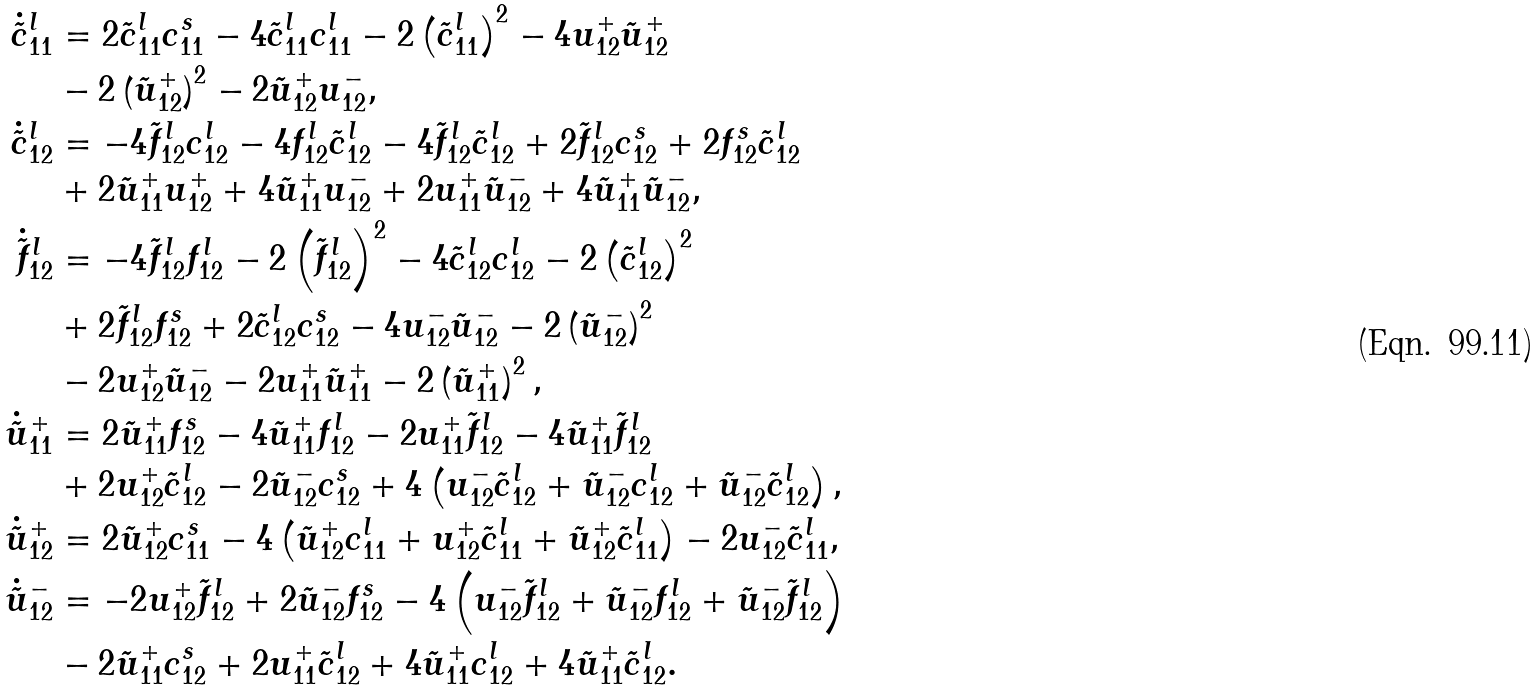Convert formula to latex. <formula><loc_0><loc_0><loc_500><loc_500>\dot { \tilde { c } } ^ { l } _ { 1 1 } & = 2 \tilde { c } ^ { l } _ { 1 1 } c ^ { s } _ { 1 1 } - 4 \tilde { c } ^ { l } _ { 1 1 } c ^ { l } _ { 1 1 } - 2 \left ( \tilde { c } ^ { l } _ { 1 1 } \right ) ^ { 2 } - 4 u _ { 1 2 } ^ { + } \tilde { u } _ { 1 2 } ^ { + } \\ & - 2 \left ( \tilde { u } _ { 1 2 } ^ { + } \right ) ^ { 2 } - 2 \tilde { u } _ { 1 2 } ^ { + } u _ { 1 2 } ^ { - } , \\ \dot { \tilde { c } } ^ { l } _ { 1 2 } & = - 4 \tilde { f } ^ { l } _ { 1 2 } c ^ { l } _ { 1 2 } - 4 f ^ { l } _ { 1 2 } \tilde { c } ^ { l } _ { 1 2 } - 4 \tilde { f } ^ { l } _ { 1 2 } \tilde { c } ^ { l } _ { 1 2 } + 2 \tilde { f } ^ { l } _ { 1 2 } c ^ { s } _ { 1 2 } + 2 f ^ { s } _ { 1 2 } \tilde { c } ^ { l } _ { 1 2 } \\ & + 2 \tilde { u } _ { 1 1 } ^ { + } u _ { 1 2 } ^ { + } + 4 \tilde { u } _ { 1 1 } ^ { + } u _ { 1 2 } ^ { - } + 2 u _ { 1 1 } ^ { + } \tilde { u } _ { 1 2 } ^ { - } + 4 \tilde { u } _ { 1 1 } ^ { + } \tilde { u } _ { 1 2 } ^ { - } , \\ \dot { \tilde { f } } ^ { l } _ { 1 2 } & = - 4 \tilde { f } ^ { l } _ { 1 2 } f ^ { l } _ { 1 2 } - 2 \left ( \tilde { f } ^ { l } _ { 1 2 } \right ) ^ { 2 } - 4 \tilde { c } ^ { l } _ { 1 2 } c ^ { l } _ { 1 2 } - 2 \left ( \tilde { c } ^ { l } _ { 1 2 } \right ) ^ { 2 } \\ & + 2 \tilde { f } ^ { l } _ { 1 2 } f ^ { s } _ { 1 2 } + 2 \tilde { c } ^ { l } _ { 1 2 } c ^ { s } _ { 1 2 } - 4 u _ { 1 2 } ^ { - } \tilde { u } _ { 1 2 } ^ { - } - 2 \left ( \tilde { u } _ { 1 2 } ^ { - } \right ) ^ { 2 } \\ & - 2 u _ { 1 2 } ^ { + } \tilde { u } _ { 1 2 } ^ { - } - 2 u _ { 1 1 } ^ { + } \tilde { u } _ { 1 1 } ^ { + } - 2 \left ( \tilde { u } _ { 1 1 } ^ { + } \right ) ^ { 2 } , \\ \dot { \tilde { u } } ^ { + } _ { 1 1 } & = 2 \tilde { u } _ { 1 1 } ^ { + } f ^ { s } _ { 1 2 } - 4 \tilde { u } _ { 1 1 } ^ { + } f ^ { l } _ { 1 2 } - 2 u _ { 1 1 } ^ { + } \tilde { f } ^ { l } _ { 1 2 } - 4 \tilde { u } _ { 1 1 } ^ { + } \tilde { f } ^ { l } _ { 1 2 } \\ & + 2 u ^ { + } _ { 1 2 } \tilde { c } ^ { l } _ { 1 2 } - 2 \tilde { u } ^ { - } _ { 1 2 } c ^ { s } _ { 1 2 } + 4 \left ( u ^ { - } _ { 1 2 } \tilde { c } ^ { l } _ { 1 2 } + \tilde { u } ^ { - } _ { 1 2 } c ^ { l } _ { 1 2 } + \tilde { u } ^ { - } _ { 1 2 } \tilde { c } ^ { l } _ { 1 2 } \right ) , \\ \dot { \tilde { u } } ^ { + } _ { 1 2 } & = 2 \tilde { u } ^ { + } _ { 1 2 } c ^ { s } _ { 1 1 } - 4 \left ( \tilde { u } ^ { + } _ { 1 2 } c ^ { l } _ { 1 1 } + u ^ { + } _ { 1 2 } \tilde { c } ^ { l } _ { 1 1 } + \tilde { u } ^ { + } _ { 1 2 } \tilde { c } ^ { l } _ { 1 1 } \right ) - 2 u ^ { - } _ { 1 2 } \tilde { c } ^ { l } _ { 1 1 } , \\ \dot { \tilde { u } } ^ { - } _ { 1 2 } & = - 2 u ^ { + } _ { 1 2 } \tilde { f } _ { 1 2 } ^ { l } + 2 \tilde { u } ^ { - } _ { 1 2 } f _ { 1 2 } ^ { s } - 4 \left ( u ^ { - } _ { 1 2 } \tilde { f } ^ { l } _ { 1 2 } + \tilde { u } ^ { - } _ { 1 2 } f ^ { l } _ { 1 2 } + \tilde { u } ^ { - } _ { 1 2 } \tilde { f } ^ { l } _ { 1 2 } \right ) \\ & - 2 \tilde { u } ^ { + } _ { 1 1 } c ^ { s } _ { 1 2 } + 2 u ^ { + } _ { 1 1 } \tilde { c } ^ { l } _ { 1 2 } + 4 \tilde { u } ^ { + } _ { 1 1 } c ^ { l } _ { 1 2 } + 4 \tilde { u } ^ { + } _ { 1 1 } \tilde { c } ^ { l } _ { 1 2 } .</formula> 